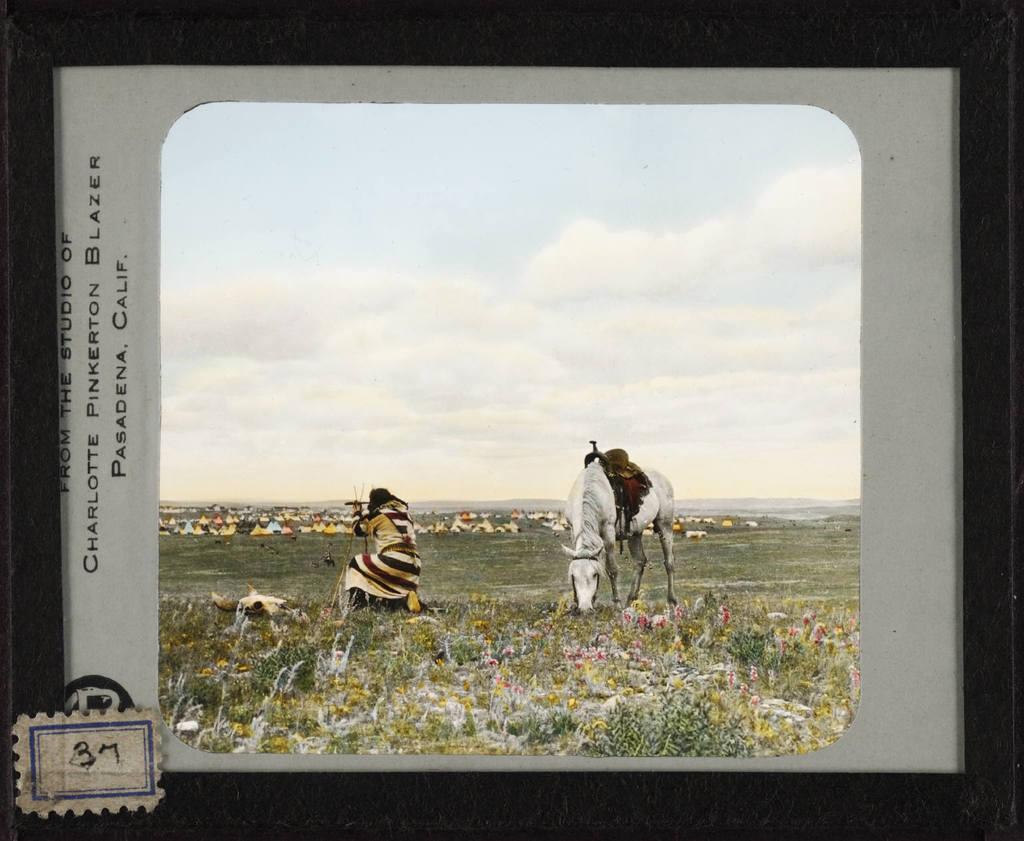What studio is mentioned this picture is from?
Offer a very short reply. Charlotte pinkerton blazer. Where was this picture taken?
Your response must be concise. Pasadena, calif. 